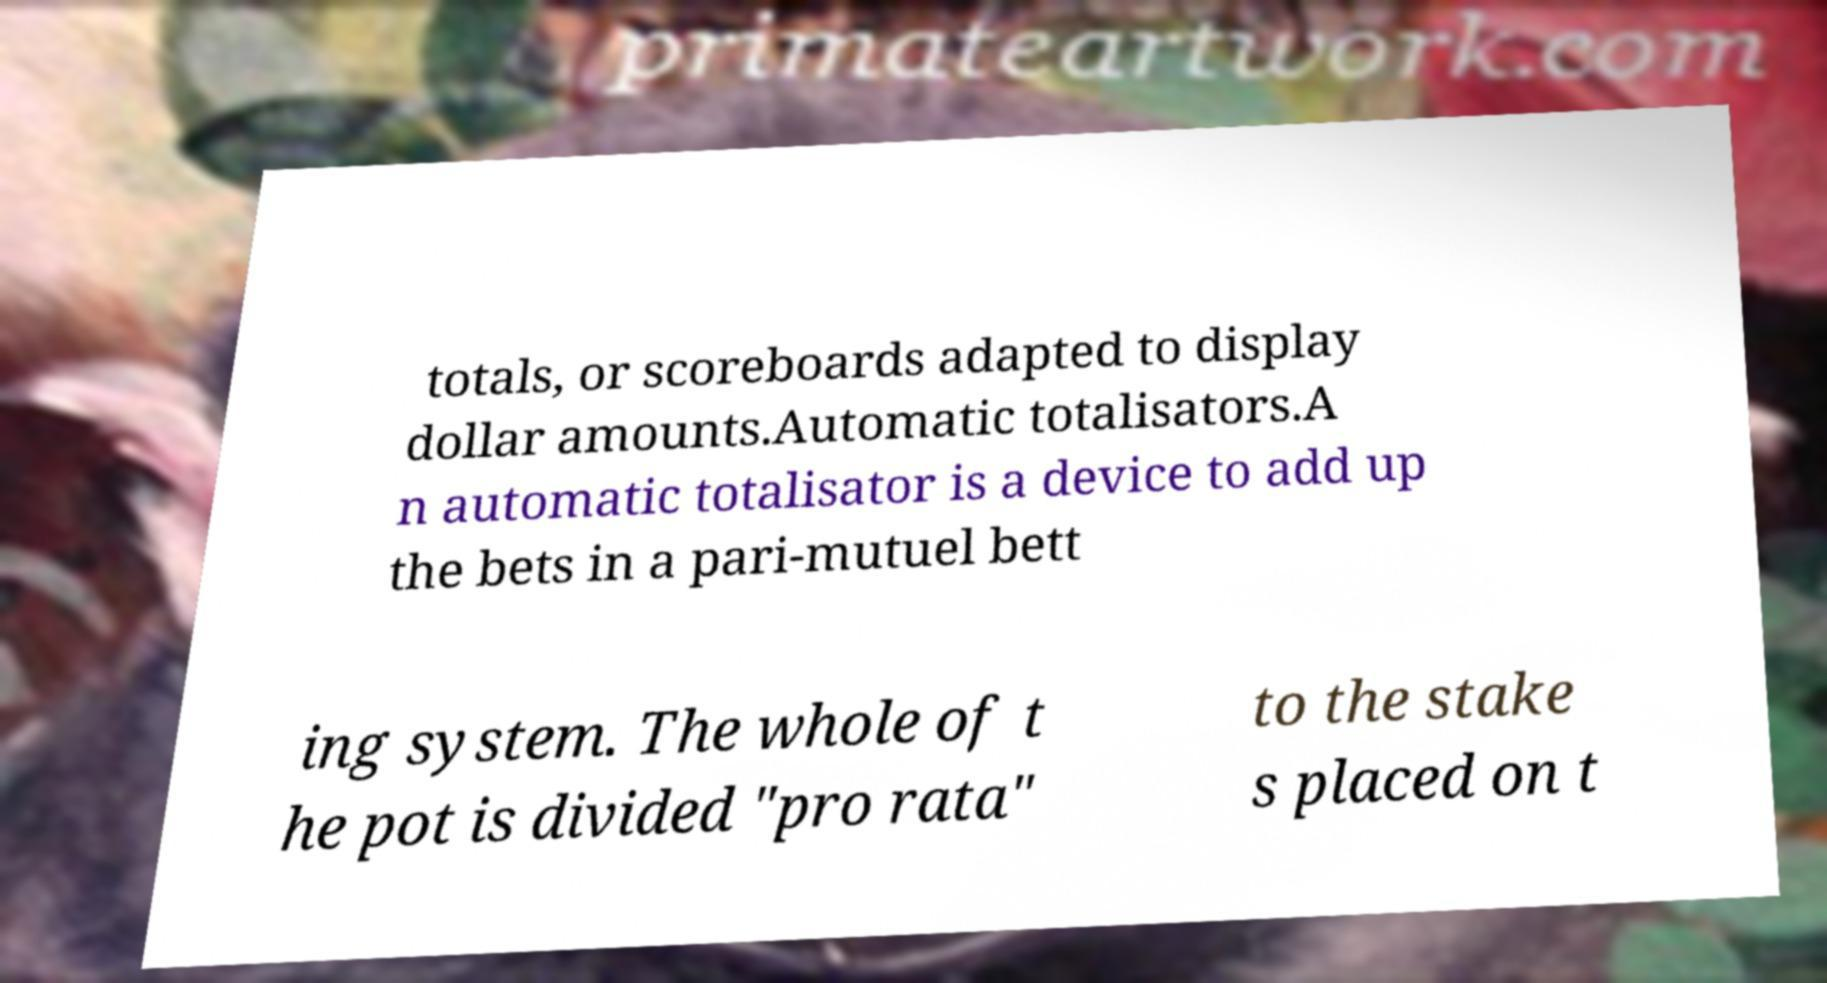Please read and relay the text visible in this image. What does it say? totals, or scoreboards adapted to display dollar amounts.Automatic totalisators.A n automatic totalisator is a device to add up the bets in a pari-mutuel bett ing system. The whole of t he pot is divided "pro rata" to the stake s placed on t 